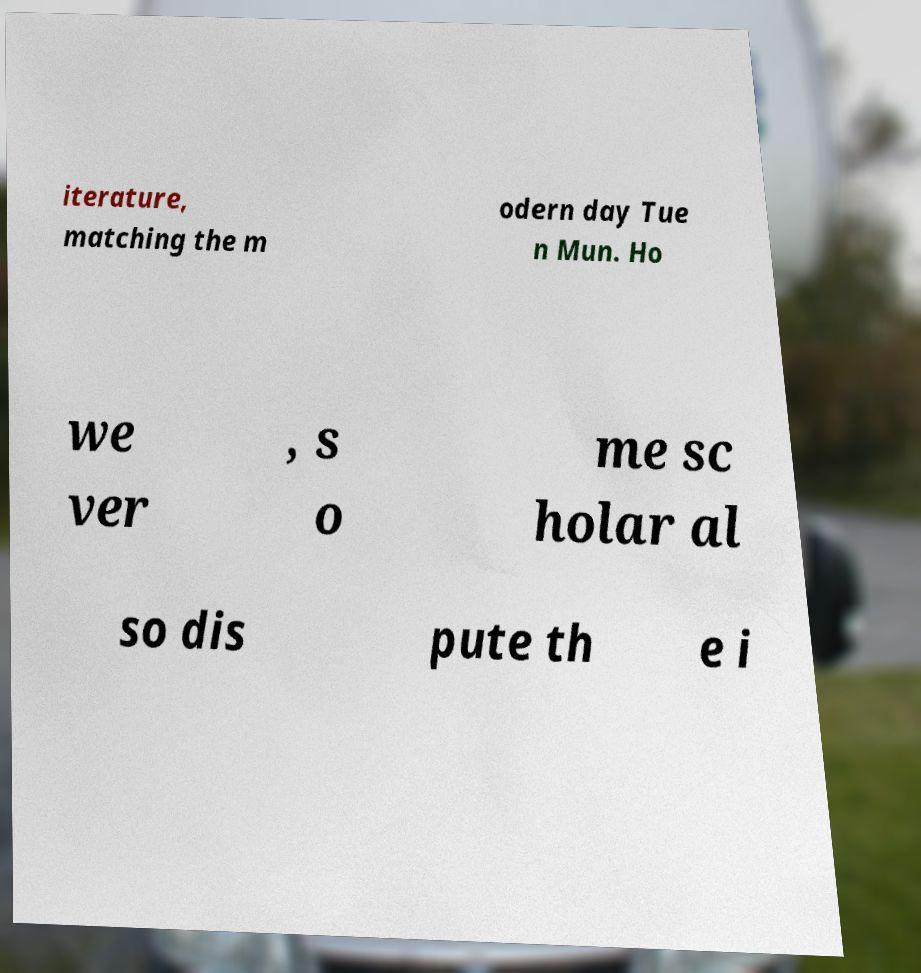Can you accurately transcribe the text from the provided image for me? iterature, matching the m odern day Tue n Mun. Ho we ver , s o me sc holar al so dis pute th e i 